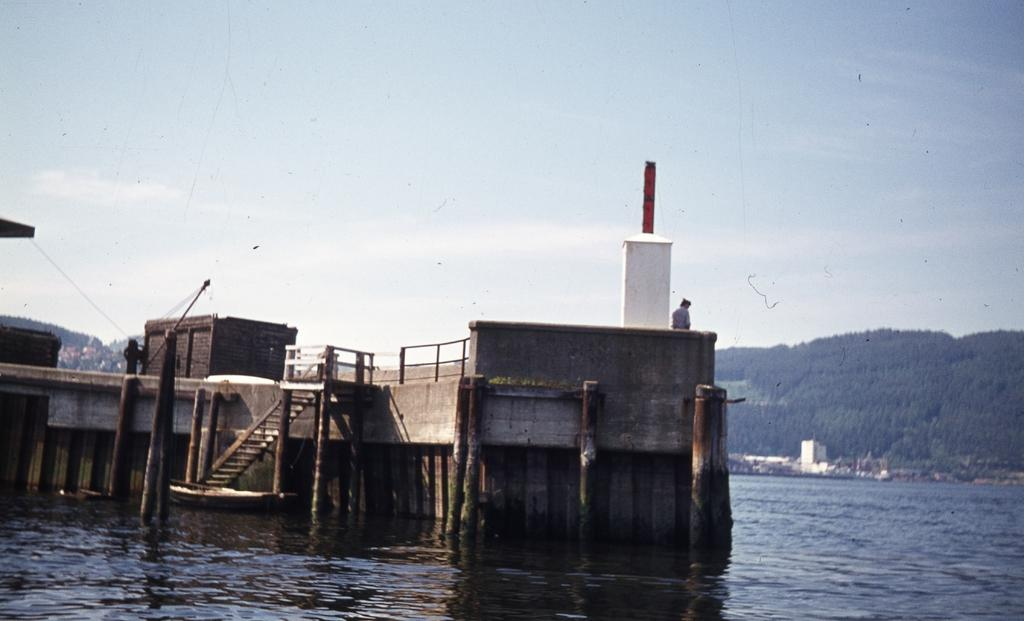What type of natural feature is present in the image? There is a river in the image. What structure can be seen near the river? There is a dock in the image. What can be seen in the background of the image? There are trees, a hill, and the sky visible in the background of the image. What is the condition of the sky in the image? The sky is visible in the background of the image, and there are clouds present. Can you tell me how many people are surprised by the person shaking the tree in the image? There is no person shaking a tree in the image, and therefore no one is surprised by such an action. 